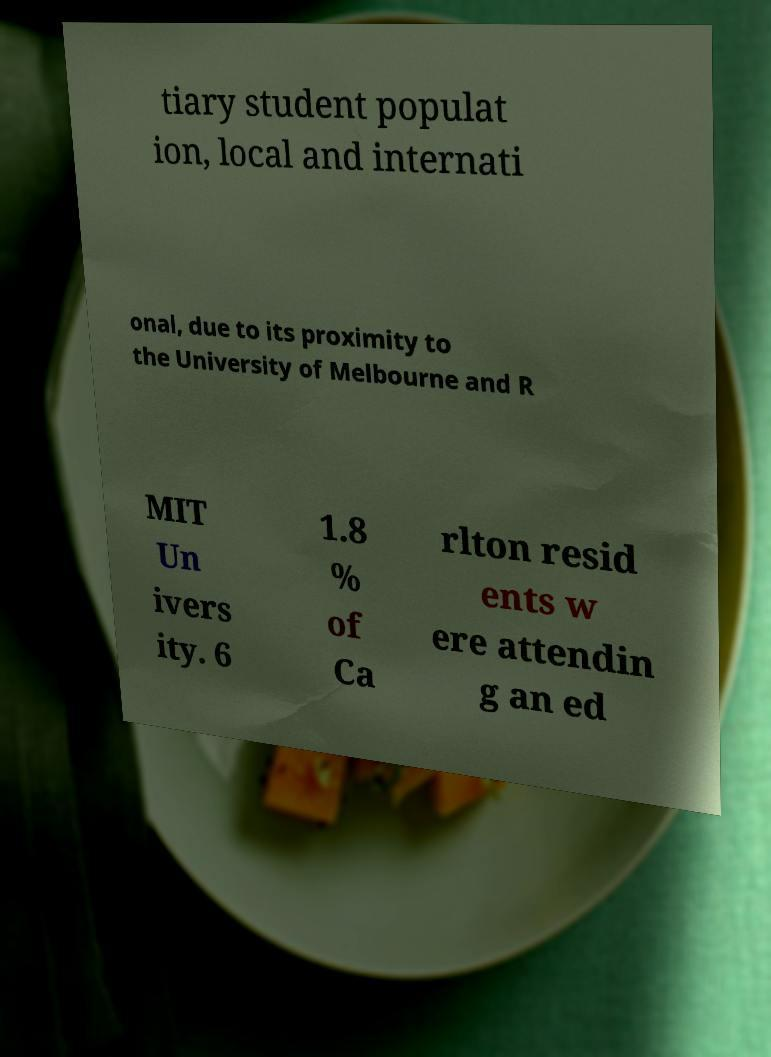Please read and relay the text visible in this image. What does it say? tiary student populat ion, local and internati onal, due to its proximity to the University of Melbourne and R MIT Un ivers ity. 6 1.8 % of Ca rlton resid ents w ere attendin g an ed 